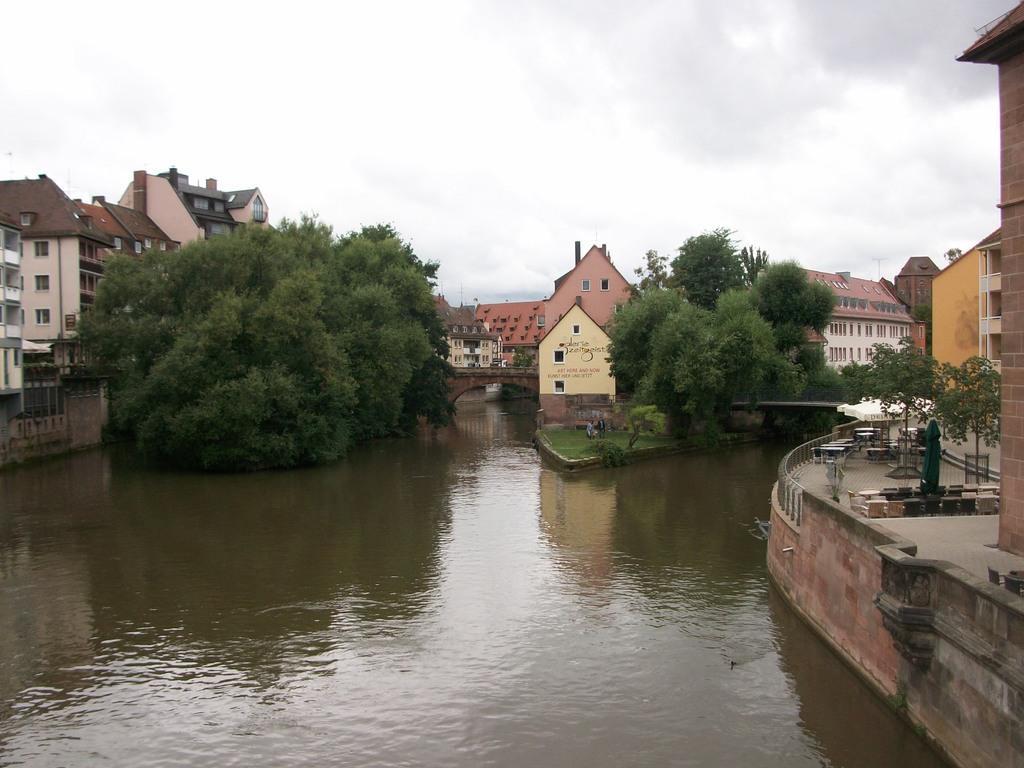How would you summarize this image in a sentence or two? In this image in the front there is water. On the right side there are tables, chairs, buildings and there is a tree. In the background there are trees and buildings and the sky is cloudy. 